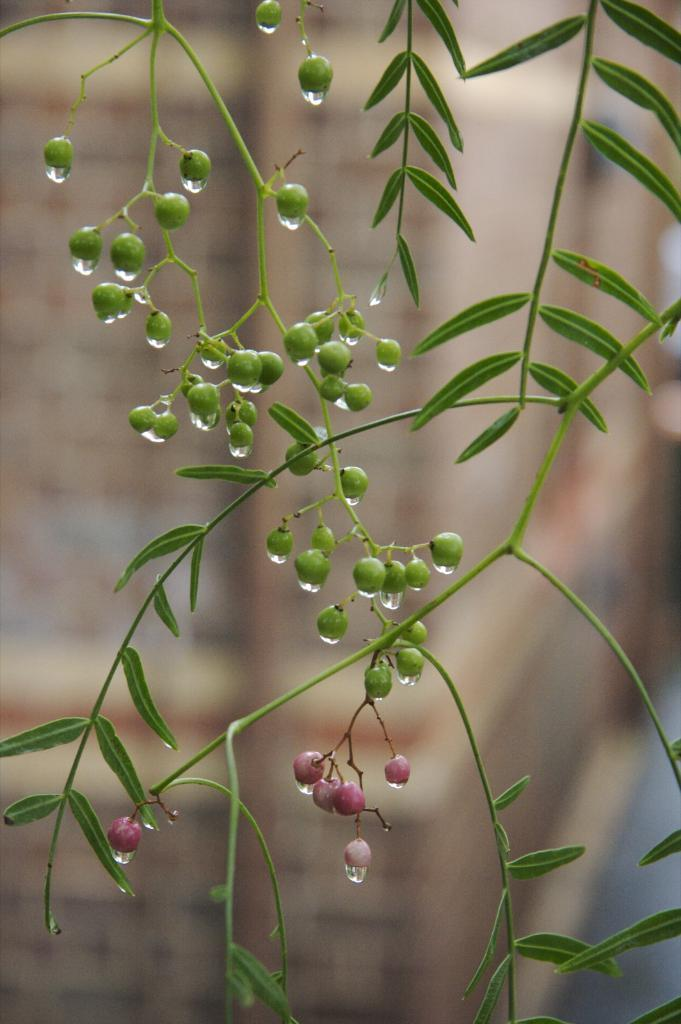What can be seen in the foreground of the image? There are leaves and fruits in the foreground of the image. Can you describe the background of the image? The background of the image is blurred. How many letters are on the rose in the image? There is no rose present in the image, and therefore no letters can be found on it. 